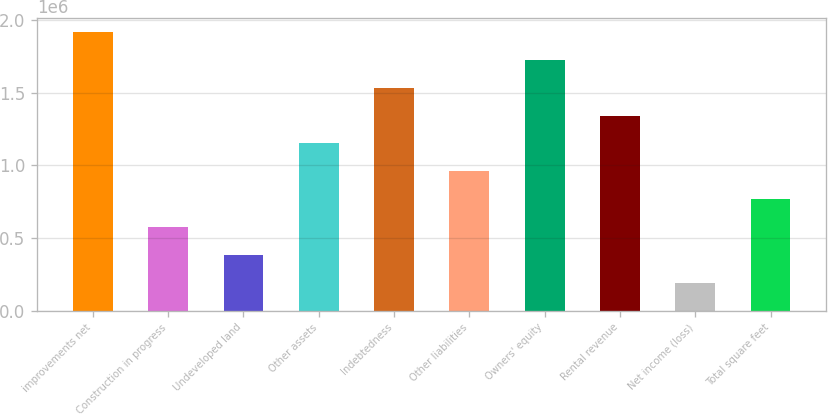Convert chart. <chart><loc_0><loc_0><loc_500><loc_500><bar_chart><fcel>improvements net<fcel>Construction in progress<fcel>Undeveloped land<fcel>Other assets<fcel>Indebtedness<fcel>Other liabilities<fcel>Owners' equity<fcel>Rental revenue<fcel>Net income (loss)<fcel>Total square feet<nl><fcel>1.91955e+06<fcel>575928<fcel>383981<fcel>1.15177e+06<fcel>1.53566e+06<fcel>959821<fcel>1.72761e+06<fcel>1.34371e+06<fcel>192035<fcel>767874<nl></chart> 